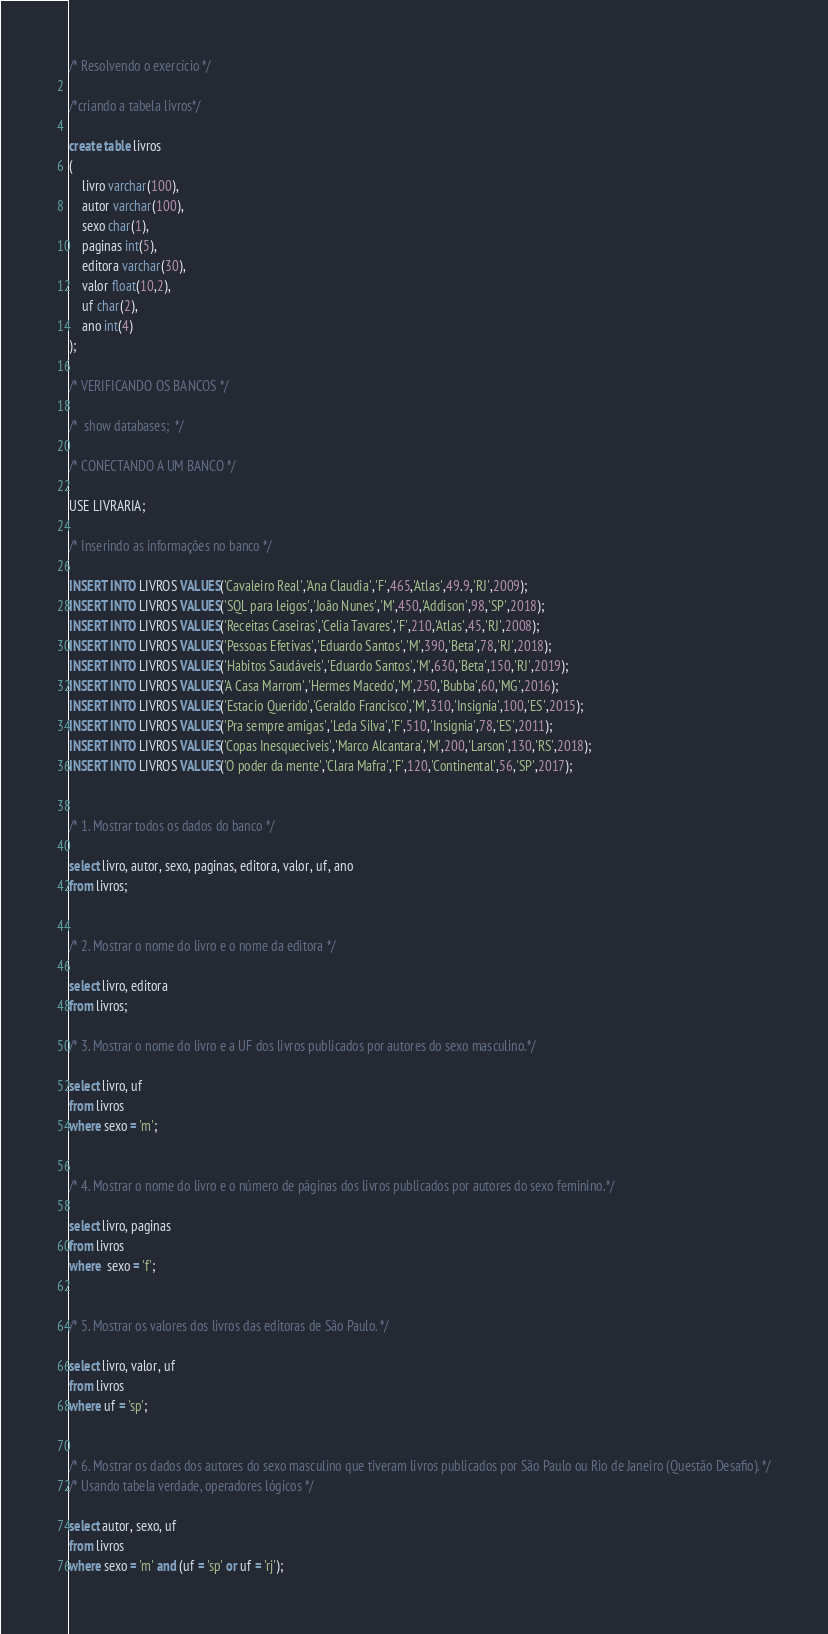Convert code to text. <code><loc_0><loc_0><loc_500><loc_500><_SQL_>/* Resolvendo o exercício */ 

/*criando a tabela livros*/

create table livros
(
    livro varchar(100),
    autor varchar(100),
    sexo char(1),
    paginas int(5),
    editora varchar(30),
    valor float(10,2),
    uf char(2),
    ano int(4)
);

/* VERIFICANDO OS BANCOS */

/*  show databases;  */

/* CONECTANDO A UM BANCO */

USE LIVRARIA;

/* Inserindo as informações no banco */

INSERT INTO LIVROS VALUES('Cavaleiro Real','Ana Claudia','F',465,'Atlas',49.9,'RJ',2009);
INSERT INTO LIVROS VALUES('SQL para leigos','João Nunes','M',450,'Addison',98,'SP',2018);
INSERT INTO LIVROS VALUES('Receitas Caseiras','Celia Tavares','F',210,'Atlas',45,'RJ',2008);
INSERT INTO LIVROS VALUES('Pessoas Efetivas','Eduardo Santos','M',390,'Beta',78,'RJ',2018);
INSERT INTO LIVROS VALUES('Habitos Saudáveis','Eduardo Santos','M',630,'Beta',150,'RJ',2019);
INSERT INTO LIVROS VALUES('A Casa Marrom','Hermes Macedo','M',250,'Bubba',60,'MG',2016);
INSERT INTO LIVROS VALUES('Estacio Querido','Geraldo Francisco','M',310,'Insignia',100,'ES',2015);
INSERT INTO LIVROS VALUES('Pra sempre amigas','Leda Silva','F',510,'Insignia',78,'ES',2011);
INSERT INTO LIVROS VALUES('Copas Inesqueciveis','Marco Alcantara','M',200,'Larson',130,'RS',2018);
INSERT INTO LIVROS VALUES('O poder da mente','Clara Mafra','F',120,'Continental',56,'SP',2017);


/* 1. Mostrar todos os dados do banco */

select livro, autor, sexo, paginas, editora, valor, uf, ano 
from livros;


/* 2. Mostrar o nome do livro e o nome da editora */

select livro, editora
from livros;

/* 3. Mostrar o nome do livro e a UF dos livros publicados por autores do sexo masculino.*/

select livro, uf
from livros
where sexo = 'm';


/* 4. Mostrar o nome do livro e o número de páginas dos livros publicados por autores do sexo feminino.*/

select livro, paginas
from livros
where  sexo = 'f';


/* 5. Mostrar os valores dos livros das editoras de São Paulo. */

select livro, valor, uf
from livros
where uf = 'sp';


/* 6. Mostrar os dados dos autores do sexo masculino que tiveram livros publicados por São Paulo ou Rio de Janeiro (Questão Desafio). */
/* Usando tabela verdade, operadores lógicos */

select autor, sexo, uf
from livros
where sexo = 'm' and (uf = 'sp' or uf = 'rj');
</code> 